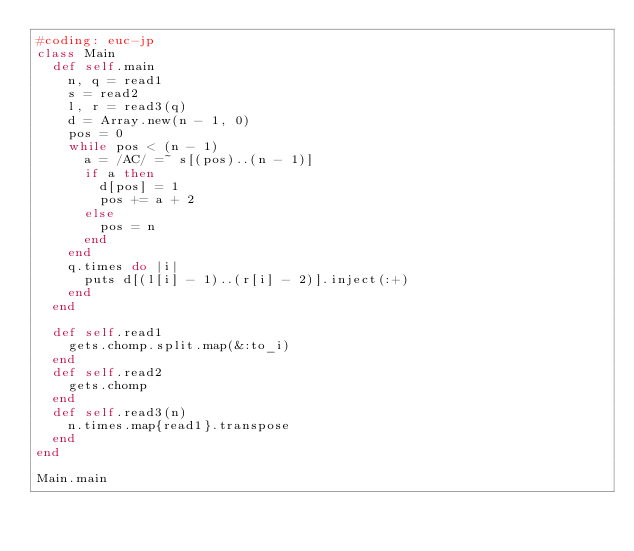<code> <loc_0><loc_0><loc_500><loc_500><_Ruby_>#coding: euc-jp
class Main
  def self.main
    n, q = read1
    s = read2
    l, r = read3(q)
    d = Array.new(n - 1, 0)
    pos = 0
    while pos < (n - 1)
      a = /AC/ =~ s[(pos)..(n - 1)]
      if a then
        d[pos] = 1
        pos += a + 2
      else
        pos = n
      end
    end
    q.times do |i|
      puts d[(l[i] - 1)..(r[i] - 2)].inject(:+)
    end
  end

  def self.read1
    gets.chomp.split.map(&:to_i)
  end
  def self.read2
    gets.chomp
  end
  def self.read3(n)
    n.times.map{read1}.transpose
  end
end

Main.main
</code> 